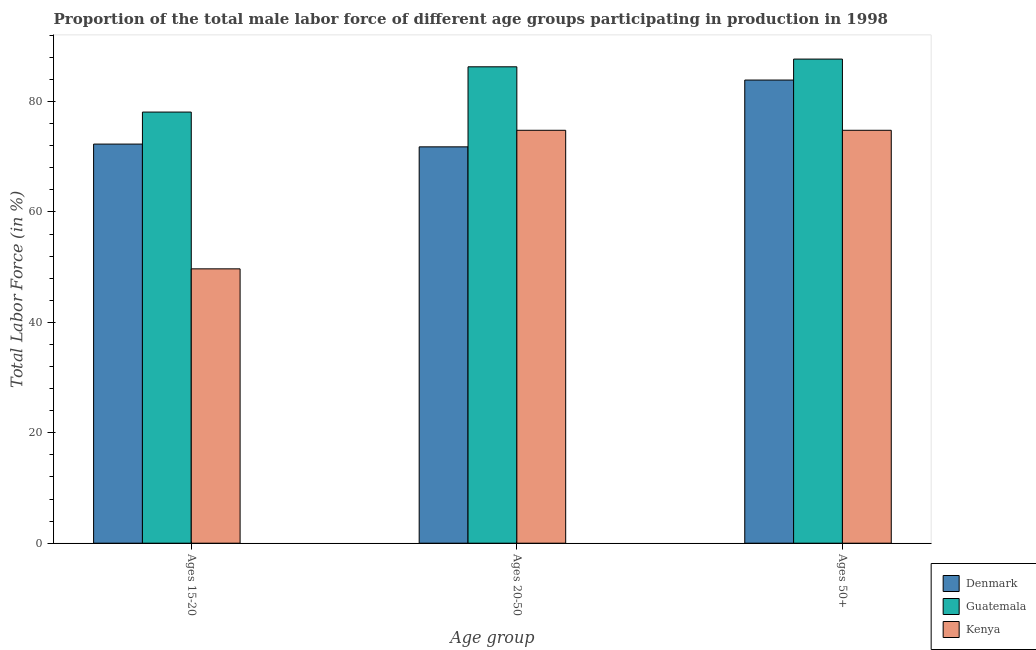How many groups of bars are there?
Your response must be concise. 3. How many bars are there on the 2nd tick from the right?
Your response must be concise. 3. What is the label of the 3rd group of bars from the left?
Ensure brevity in your answer.  Ages 50+. What is the percentage of male labor force within the age group 15-20 in Denmark?
Ensure brevity in your answer.  72.3. Across all countries, what is the maximum percentage of male labor force above age 50?
Keep it short and to the point. 87.7. Across all countries, what is the minimum percentage of male labor force above age 50?
Keep it short and to the point. 74.8. In which country was the percentage of male labor force within the age group 20-50 maximum?
Ensure brevity in your answer.  Guatemala. In which country was the percentage of male labor force within the age group 20-50 minimum?
Provide a succinct answer. Denmark. What is the total percentage of male labor force within the age group 20-50 in the graph?
Ensure brevity in your answer.  232.9. What is the difference between the percentage of male labor force above age 50 in Denmark and that in Guatemala?
Offer a terse response. -3.8. What is the difference between the percentage of male labor force within the age group 20-50 in Denmark and the percentage of male labor force above age 50 in Guatemala?
Offer a terse response. -15.9. What is the average percentage of male labor force within the age group 20-50 per country?
Keep it short and to the point. 77.63. What is the difference between the percentage of male labor force within the age group 20-50 and percentage of male labor force above age 50 in Guatemala?
Your response must be concise. -1.4. In how many countries, is the percentage of male labor force above age 50 greater than 32 %?
Make the answer very short. 3. What is the ratio of the percentage of male labor force within the age group 20-50 in Denmark to that in Guatemala?
Offer a terse response. 0.83. What is the difference between the highest and the second highest percentage of male labor force above age 50?
Make the answer very short. 3.8. What is the difference between the highest and the lowest percentage of male labor force above age 50?
Your answer should be compact. 12.9. In how many countries, is the percentage of male labor force within the age group 15-20 greater than the average percentage of male labor force within the age group 15-20 taken over all countries?
Your response must be concise. 2. What does the 1st bar from the left in Ages 50+ represents?
Provide a succinct answer. Denmark. What does the 2nd bar from the right in Ages 50+ represents?
Provide a short and direct response. Guatemala. How many countries are there in the graph?
Ensure brevity in your answer.  3. Are the values on the major ticks of Y-axis written in scientific E-notation?
Your response must be concise. No. How many legend labels are there?
Offer a very short reply. 3. How are the legend labels stacked?
Make the answer very short. Vertical. What is the title of the graph?
Make the answer very short. Proportion of the total male labor force of different age groups participating in production in 1998. What is the label or title of the X-axis?
Offer a terse response. Age group. What is the label or title of the Y-axis?
Offer a terse response. Total Labor Force (in %). What is the Total Labor Force (in %) of Denmark in Ages 15-20?
Keep it short and to the point. 72.3. What is the Total Labor Force (in %) of Guatemala in Ages 15-20?
Keep it short and to the point. 78.1. What is the Total Labor Force (in %) of Kenya in Ages 15-20?
Offer a very short reply. 49.7. What is the Total Labor Force (in %) of Denmark in Ages 20-50?
Keep it short and to the point. 71.8. What is the Total Labor Force (in %) in Guatemala in Ages 20-50?
Offer a very short reply. 86.3. What is the Total Labor Force (in %) in Kenya in Ages 20-50?
Provide a succinct answer. 74.8. What is the Total Labor Force (in %) of Denmark in Ages 50+?
Ensure brevity in your answer.  83.9. What is the Total Labor Force (in %) of Guatemala in Ages 50+?
Your response must be concise. 87.7. What is the Total Labor Force (in %) of Kenya in Ages 50+?
Offer a very short reply. 74.8. Across all Age group, what is the maximum Total Labor Force (in %) of Denmark?
Give a very brief answer. 83.9. Across all Age group, what is the maximum Total Labor Force (in %) in Guatemala?
Your response must be concise. 87.7. Across all Age group, what is the maximum Total Labor Force (in %) in Kenya?
Keep it short and to the point. 74.8. Across all Age group, what is the minimum Total Labor Force (in %) in Denmark?
Provide a short and direct response. 71.8. Across all Age group, what is the minimum Total Labor Force (in %) in Guatemala?
Your answer should be compact. 78.1. Across all Age group, what is the minimum Total Labor Force (in %) of Kenya?
Offer a very short reply. 49.7. What is the total Total Labor Force (in %) in Denmark in the graph?
Give a very brief answer. 228. What is the total Total Labor Force (in %) in Guatemala in the graph?
Give a very brief answer. 252.1. What is the total Total Labor Force (in %) of Kenya in the graph?
Offer a very short reply. 199.3. What is the difference between the Total Labor Force (in %) in Guatemala in Ages 15-20 and that in Ages 20-50?
Keep it short and to the point. -8.2. What is the difference between the Total Labor Force (in %) of Kenya in Ages 15-20 and that in Ages 20-50?
Give a very brief answer. -25.1. What is the difference between the Total Labor Force (in %) in Denmark in Ages 15-20 and that in Ages 50+?
Your answer should be very brief. -11.6. What is the difference between the Total Labor Force (in %) of Guatemala in Ages 15-20 and that in Ages 50+?
Your answer should be very brief. -9.6. What is the difference between the Total Labor Force (in %) in Kenya in Ages 15-20 and that in Ages 50+?
Your answer should be very brief. -25.1. What is the difference between the Total Labor Force (in %) of Denmark in Ages 20-50 and that in Ages 50+?
Give a very brief answer. -12.1. What is the difference between the Total Labor Force (in %) of Guatemala in Ages 15-20 and the Total Labor Force (in %) of Kenya in Ages 20-50?
Offer a very short reply. 3.3. What is the difference between the Total Labor Force (in %) in Denmark in Ages 15-20 and the Total Labor Force (in %) in Guatemala in Ages 50+?
Offer a very short reply. -15.4. What is the difference between the Total Labor Force (in %) in Denmark in Ages 15-20 and the Total Labor Force (in %) in Kenya in Ages 50+?
Make the answer very short. -2.5. What is the difference between the Total Labor Force (in %) of Guatemala in Ages 15-20 and the Total Labor Force (in %) of Kenya in Ages 50+?
Keep it short and to the point. 3.3. What is the difference between the Total Labor Force (in %) of Denmark in Ages 20-50 and the Total Labor Force (in %) of Guatemala in Ages 50+?
Your answer should be very brief. -15.9. What is the difference between the Total Labor Force (in %) in Denmark in Ages 20-50 and the Total Labor Force (in %) in Kenya in Ages 50+?
Offer a terse response. -3. What is the difference between the Total Labor Force (in %) in Guatemala in Ages 20-50 and the Total Labor Force (in %) in Kenya in Ages 50+?
Give a very brief answer. 11.5. What is the average Total Labor Force (in %) of Guatemala per Age group?
Your response must be concise. 84.03. What is the average Total Labor Force (in %) of Kenya per Age group?
Your response must be concise. 66.43. What is the difference between the Total Labor Force (in %) in Denmark and Total Labor Force (in %) in Kenya in Ages 15-20?
Offer a very short reply. 22.6. What is the difference between the Total Labor Force (in %) of Guatemala and Total Labor Force (in %) of Kenya in Ages 15-20?
Offer a very short reply. 28.4. What is the difference between the Total Labor Force (in %) in Denmark and Total Labor Force (in %) in Kenya in Ages 20-50?
Offer a very short reply. -3. What is the difference between the Total Labor Force (in %) of Denmark and Total Labor Force (in %) of Kenya in Ages 50+?
Keep it short and to the point. 9.1. What is the difference between the Total Labor Force (in %) of Guatemala and Total Labor Force (in %) of Kenya in Ages 50+?
Ensure brevity in your answer.  12.9. What is the ratio of the Total Labor Force (in %) in Denmark in Ages 15-20 to that in Ages 20-50?
Offer a very short reply. 1.01. What is the ratio of the Total Labor Force (in %) of Guatemala in Ages 15-20 to that in Ages 20-50?
Offer a terse response. 0.91. What is the ratio of the Total Labor Force (in %) of Kenya in Ages 15-20 to that in Ages 20-50?
Your answer should be very brief. 0.66. What is the ratio of the Total Labor Force (in %) in Denmark in Ages 15-20 to that in Ages 50+?
Offer a terse response. 0.86. What is the ratio of the Total Labor Force (in %) of Guatemala in Ages 15-20 to that in Ages 50+?
Provide a succinct answer. 0.89. What is the ratio of the Total Labor Force (in %) in Kenya in Ages 15-20 to that in Ages 50+?
Your answer should be very brief. 0.66. What is the ratio of the Total Labor Force (in %) of Denmark in Ages 20-50 to that in Ages 50+?
Provide a short and direct response. 0.86. What is the ratio of the Total Labor Force (in %) of Guatemala in Ages 20-50 to that in Ages 50+?
Your answer should be very brief. 0.98. What is the difference between the highest and the second highest Total Labor Force (in %) of Denmark?
Ensure brevity in your answer.  11.6. What is the difference between the highest and the lowest Total Labor Force (in %) in Guatemala?
Your answer should be compact. 9.6. What is the difference between the highest and the lowest Total Labor Force (in %) in Kenya?
Provide a succinct answer. 25.1. 